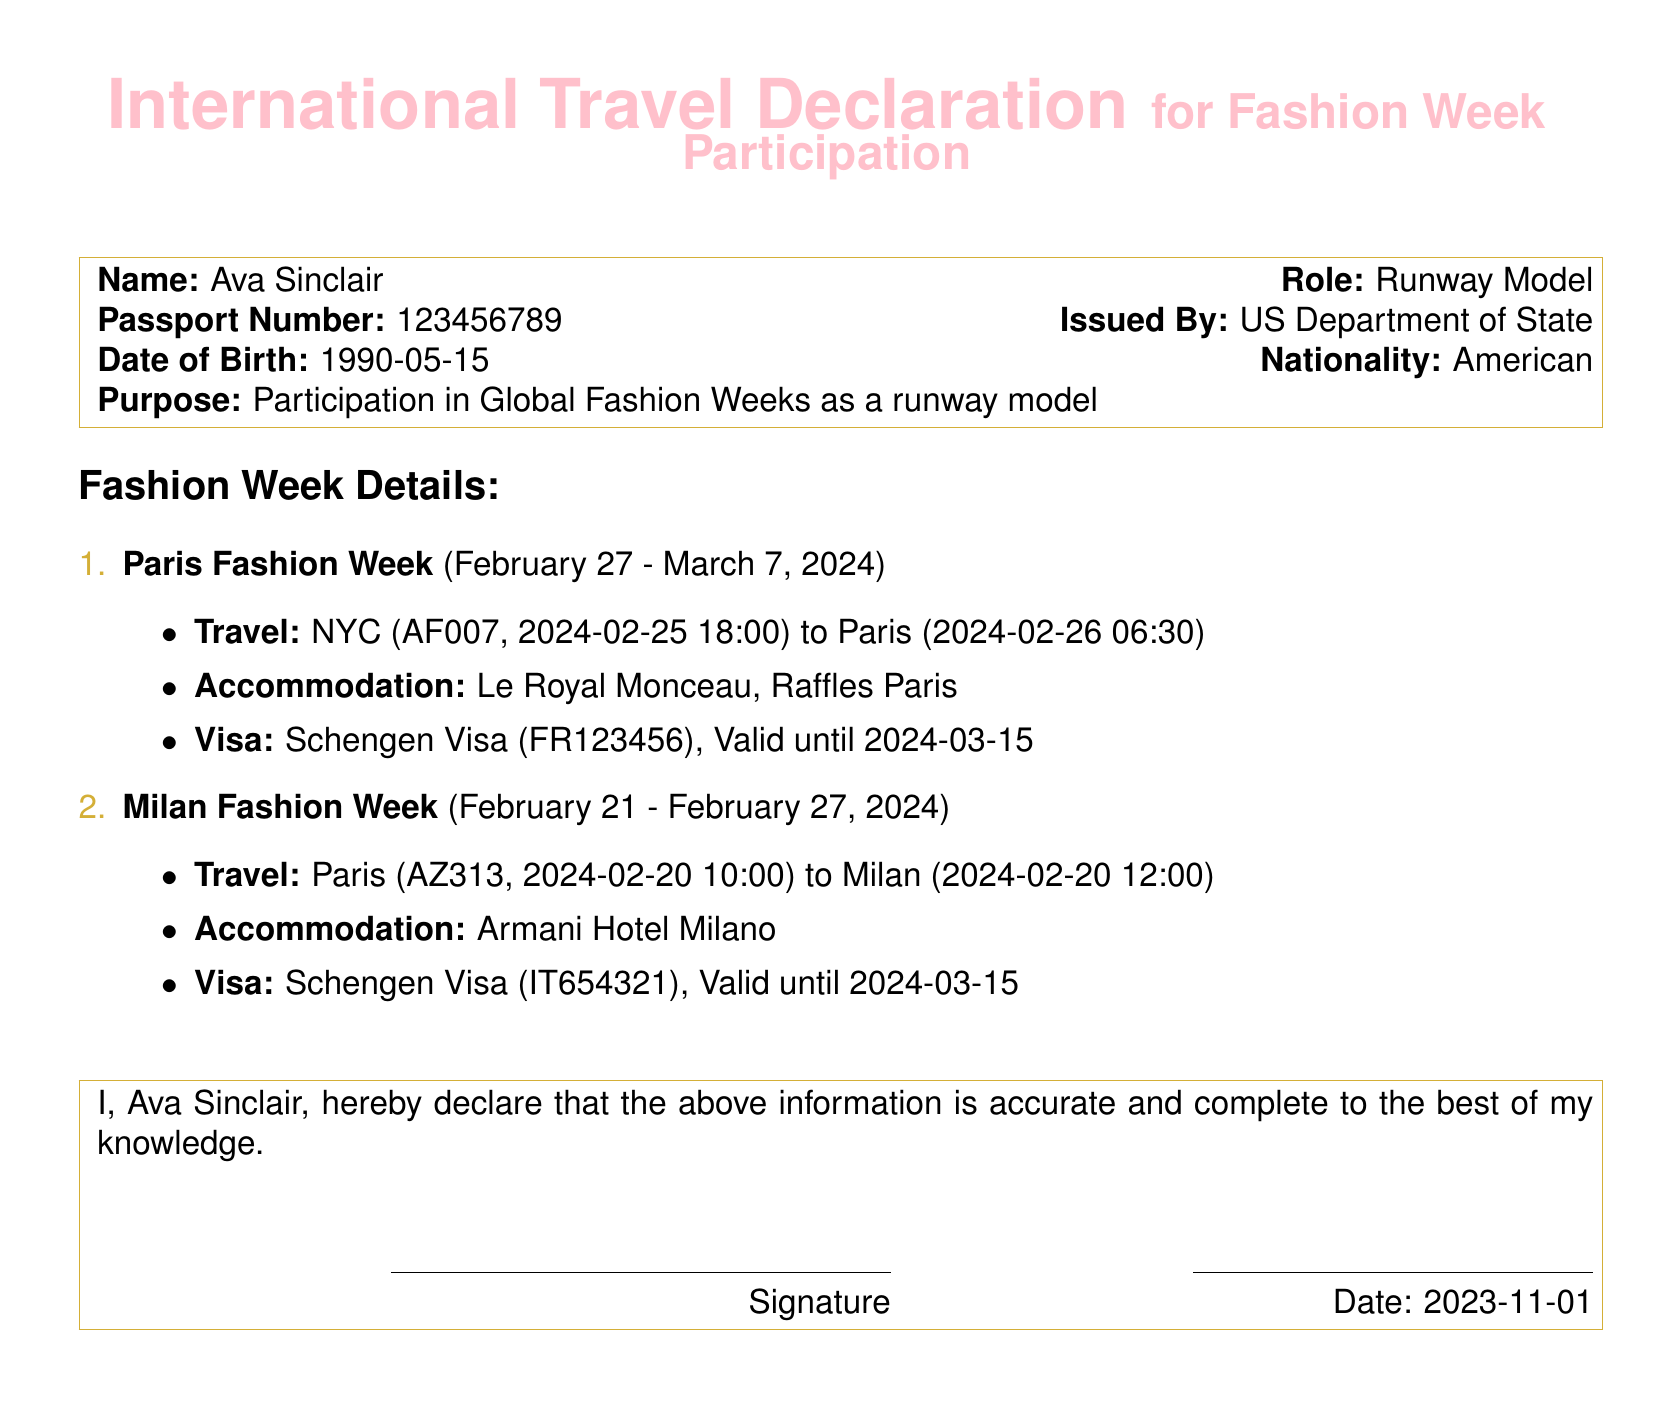What is the name of the model? The model's name is explicitly stated in the document under the name section.
Answer: Ava Sinclair What is the purpose of the travel declaration? The purpose is mentioned clearly in the document.
Answer: Participation in Global Fashion Weeks as a runway model What is the passport number? The passport number is provided directly in the document.
Answer: 123456789 When does Paris Fashion Week occur? The dates for Paris Fashion Week are listed in the document.
Answer: February 27 - March 7, 2024 What is the accommodation for Milan Fashion Week? The accommodation details for Milan Fashion Week are specified in the document.
Answer: Armani Hotel Milano How long is the Schengen Visa valid? The validity period for the Schengen Visa is mentioned in the visa detail sections.
Answer: Valid until 2024-03-15 What is the travel date from NYC to Paris? The travel date from NYC to Paris is specified in the document.
Answer: 2024-02-25 What airline is used for the flight from Paris to Milan? The airline for the flight from Paris to Milan is mentioned in the travel details.
Answer: AZ313 Who issued the passport? The issuing authority of the passport is mentioned in the document.
Answer: US Department of State 